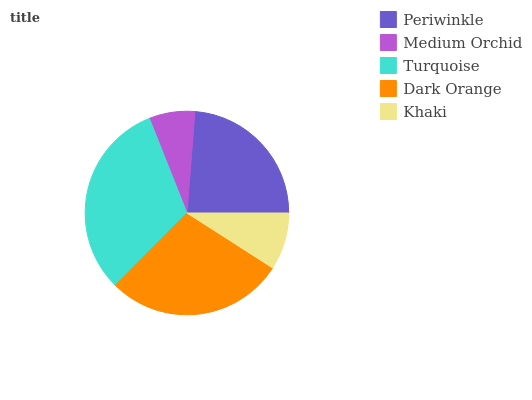Is Medium Orchid the minimum?
Answer yes or no. Yes. Is Turquoise the maximum?
Answer yes or no. Yes. Is Turquoise the minimum?
Answer yes or no. No. Is Medium Orchid the maximum?
Answer yes or no. No. Is Turquoise greater than Medium Orchid?
Answer yes or no. Yes. Is Medium Orchid less than Turquoise?
Answer yes or no. Yes. Is Medium Orchid greater than Turquoise?
Answer yes or no. No. Is Turquoise less than Medium Orchid?
Answer yes or no. No. Is Periwinkle the high median?
Answer yes or no. Yes. Is Periwinkle the low median?
Answer yes or no. Yes. Is Khaki the high median?
Answer yes or no. No. Is Turquoise the low median?
Answer yes or no. No. 